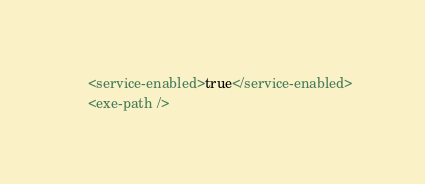<code> <loc_0><loc_0><loc_500><loc_500><_XML_>    <service-enabled>true</service-enabled>
    <exe-path /></code> 